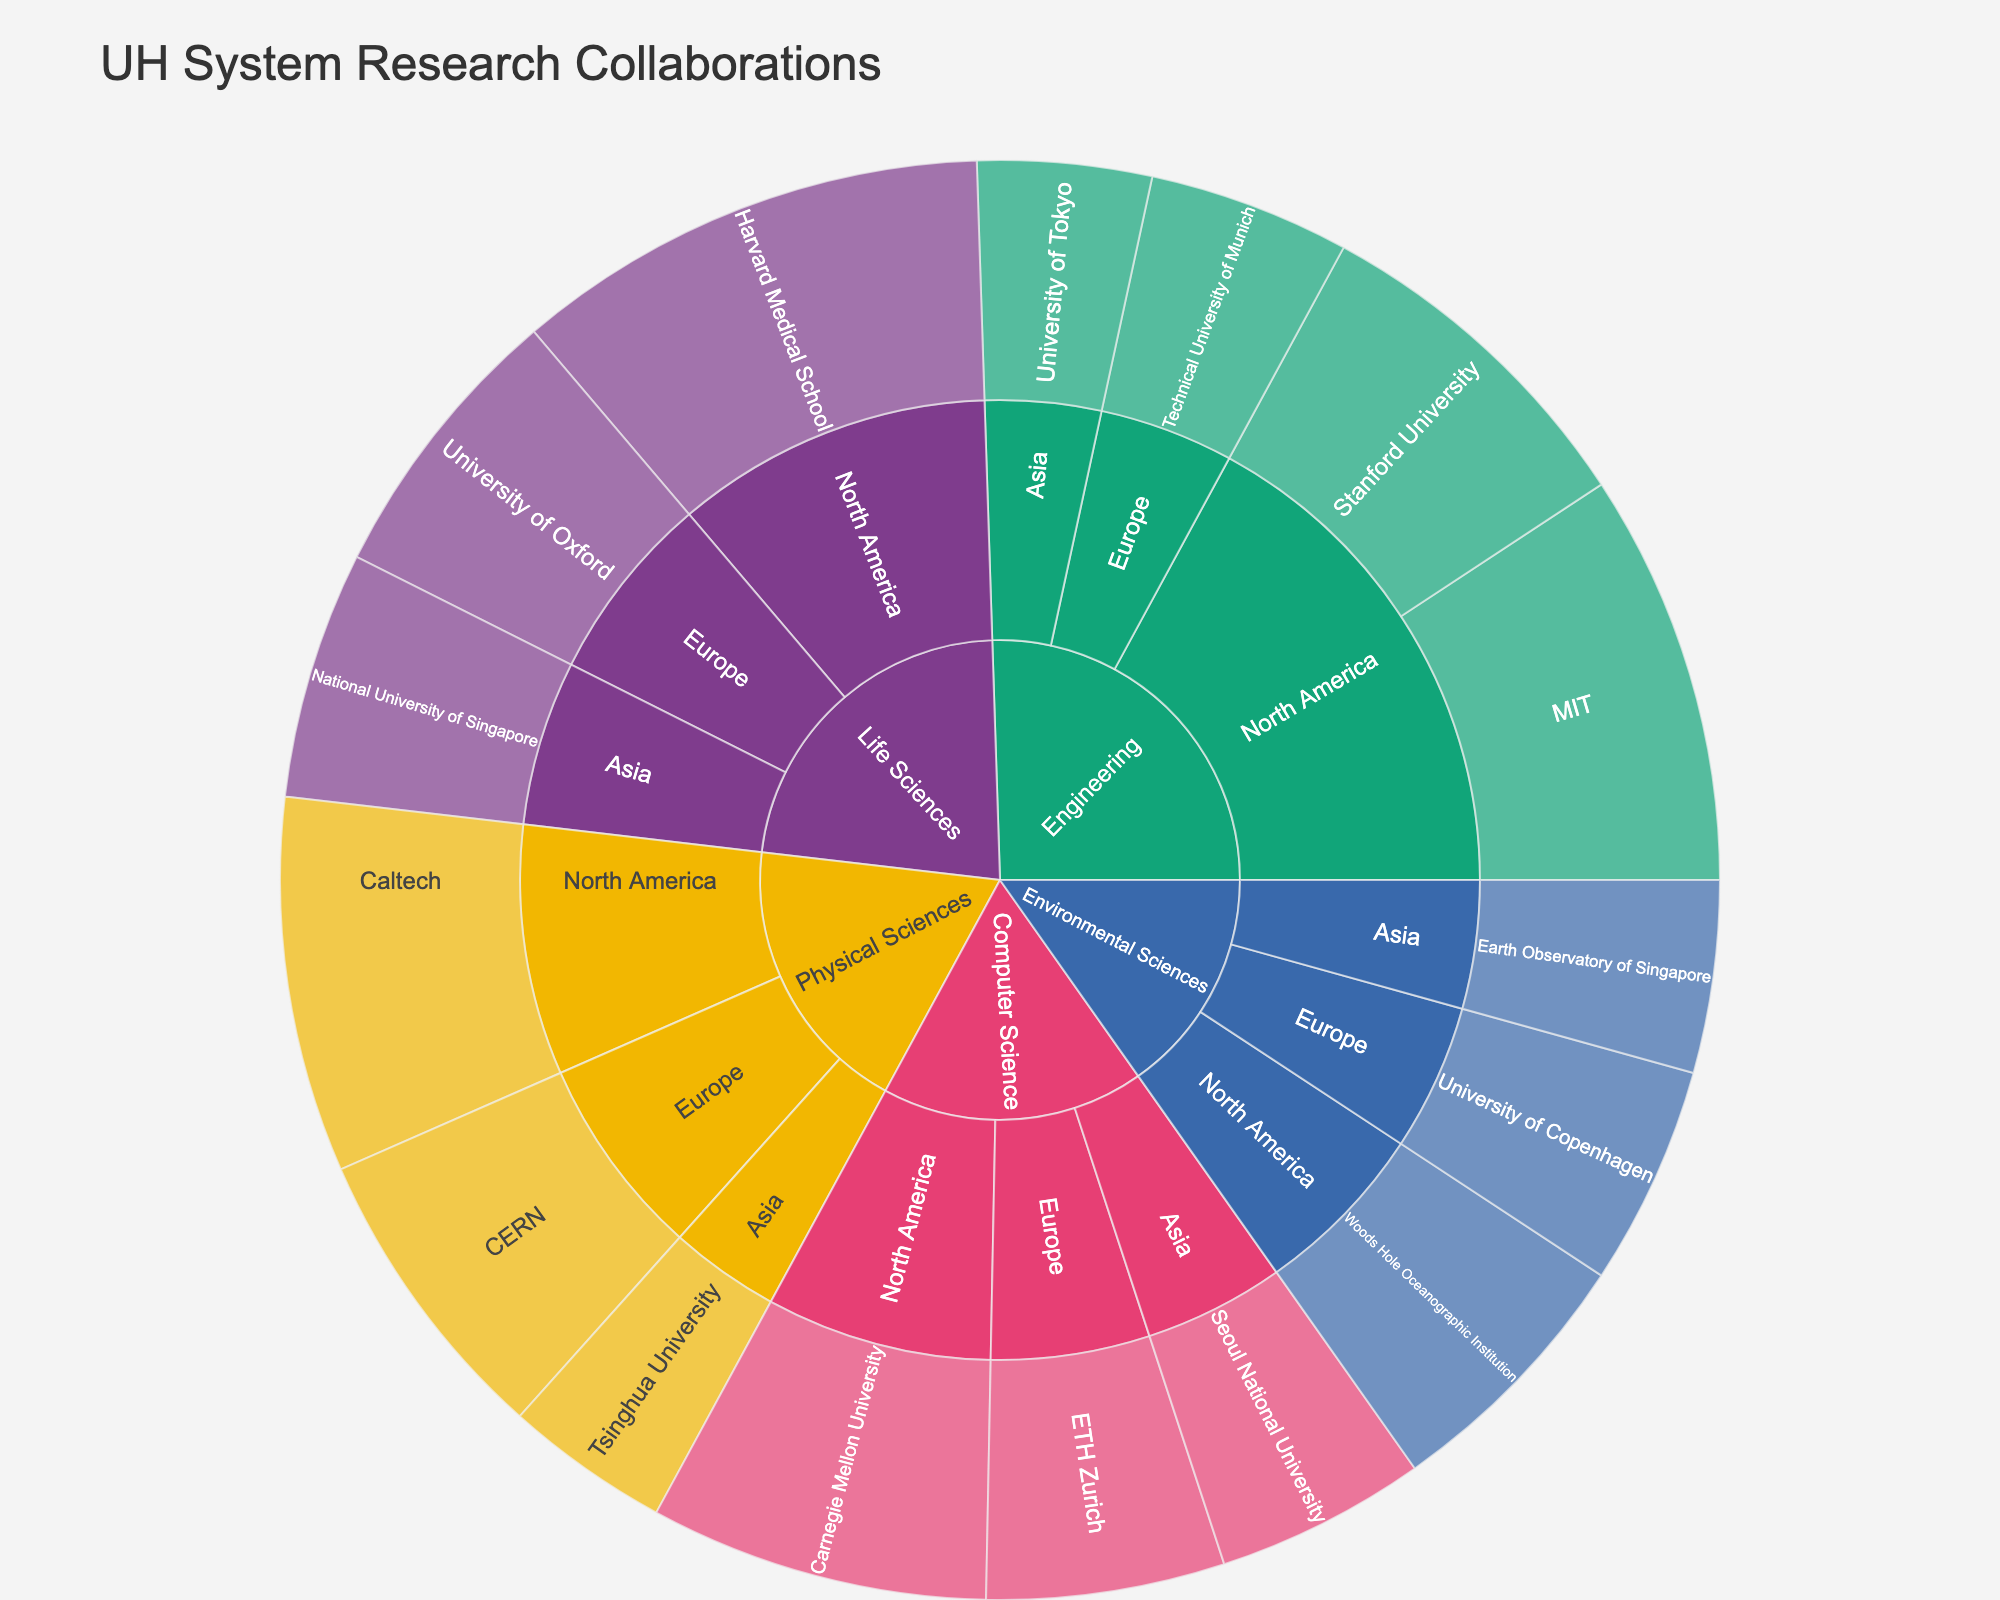Which institution in North America has the most research collaborations in Life Sciences? On the Sunburst plot, locate the 'Life Sciences' section, then North America, and check the number of collaborations for each institution. Harvard Medical School has the highest with 52 collaborations.
Answer: Harvard Medical School How many total collaborations are there in Environmental Sciences across all regions? Locate the 'Environmental Sciences' section in the Sunburst plot and add the collaborations from North America, Europe, and Asia: 29 (North America) + 24 (Europe) + 21 (Asia) = 74.
Answer: 74 Which region has the least number of collaborations in Computer Science? In the Sunburst plot, go to the 'Computer Science' section and compare the number of collaborations in North America, Europe, and Asia. Asia has the least with 23 collaborations.
Answer: Asia Is the number of collaborations in Engineering with North American institutions greater than the total collaborations in Physical Sciences? First, add up the collaborations in Engineering with North American institutions: 45 (MIT) + 38 (Stanford University) = 83. Then, add up the total collaborations in Physical Sciences: 41 (Caltech) + 33 (CERN) + 18 (Tsinghua University) = 92. 83 is not greater than 92.
Answer: No Which institution has the highest number of collaborations in Europe and in which field? Locate the European section and find the institution with the highest collaborations: University of Oxford in Life Sciences with 31 collaborations.
Answer: University of Oxford, Life Sciences What is the difference between the total collaborations in Life Sciences and Environmental Sciences? Add the collaborations in Life Sciences: 52 (Harvard Medical School) + 31 (University of Oxford) + 27 (National University of Singapore) = 110. Add the collaborations in Environmental Sciences: 29 (Woods Hole) + 24 (University of Copenhagen) + 21 (Earth Observatory of Singapore) = 74. The difference is 110 - 74 = 36.
Answer: 36 How many fields have at least one institution in Asia? Identify which fields have collaborations in Asia by locating each section and counting those that have sub-sections in Asia. There are Engineering, Life Sciences, Physical Sciences, Environmental Sciences, and Computer Science, resulting in 5 fields.
Answer: 5 Compare the number of collaborations between MIT and Caltech. Locate MIT and Caltech in the Sunburst plot and compare their collaboration numbers: MIT has 45 collaborations, and Caltech has 41.
Answer: MIT has more What is the average number of collaborations per institution in Environmental Sciences? Add the collaborations in Environmental Sciences: 29 (Woods Hole) + 24 (University of Copenhagen) + 21 (Earth Observatory of Singapore) = 74. There are 3 institutions, so the average is 74 / 3 = 24.67.
Answer: 24.67 Which institution in Asia contributes the most to research collaborations? Locate the Asian section and compare the number of collaborations for each institution: University of Tokyo (19), National University of Singapore (27), Tsinghua University (18), Earth Observatory of Singapore (21), Seoul National University (23). National University of Singapore has the most with 27 collaborations.
Answer: National University of Singapore 